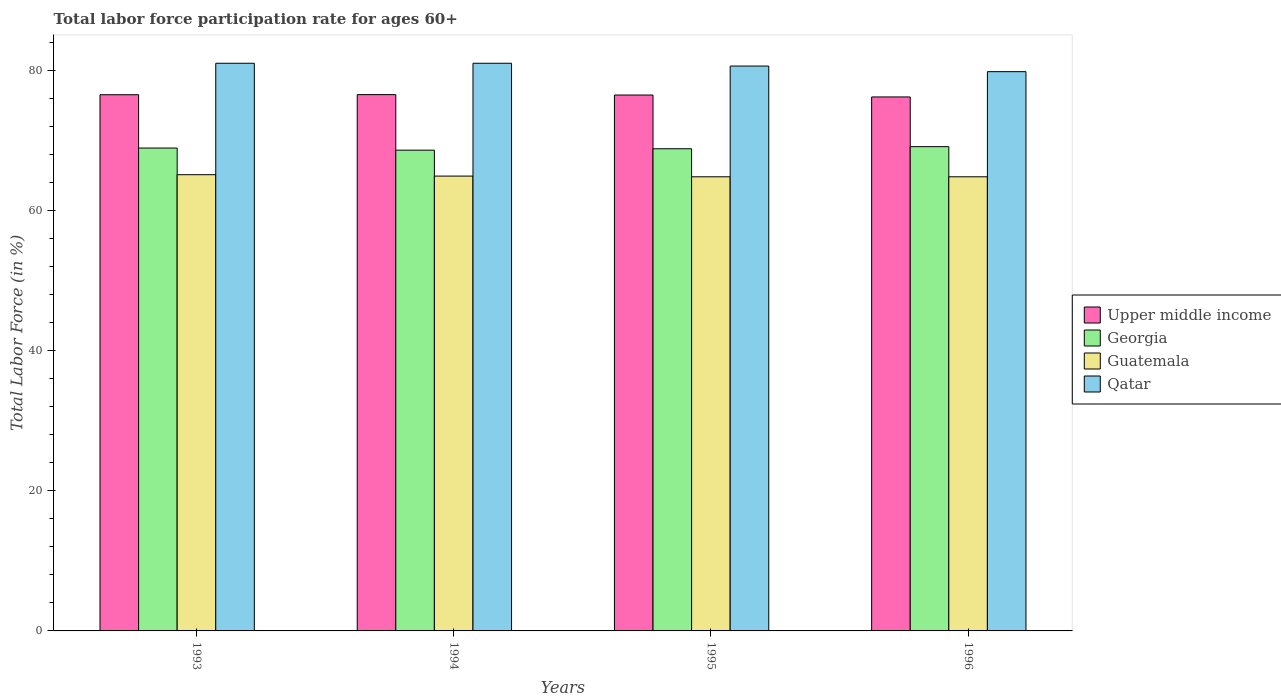How many groups of bars are there?
Offer a terse response. 4. Are the number of bars per tick equal to the number of legend labels?
Ensure brevity in your answer.  Yes. In how many cases, is the number of bars for a given year not equal to the number of legend labels?
Give a very brief answer. 0. What is the labor force participation rate in Georgia in 1995?
Provide a short and direct response. 68.8. Across all years, what is the maximum labor force participation rate in Georgia?
Keep it short and to the point. 69.1. Across all years, what is the minimum labor force participation rate in Guatemala?
Provide a succinct answer. 64.8. In which year was the labor force participation rate in Qatar maximum?
Offer a terse response. 1993. In which year was the labor force participation rate in Guatemala minimum?
Your answer should be compact. 1995. What is the total labor force participation rate in Guatemala in the graph?
Give a very brief answer. 259.6. What is the difference between the labor force participation rate in Georgia in 1993 and that in 1994?
Your answer should be compact. 0.3. What is the difference between the labor force participation rate in Qatar in 1993 and the labor force participation rate in Upper middle income in 1995?
Provide a short and direct response. 4.53. What is the average labor force participation rate in Georgia per year?
Provide a short and direct response. 68.85. In the year 1996, what is the difference between the labor force participation rate in Qatar and labor force participation rate in Upper middle income?
Offer a terse response. 3.61. In how many years, is the labor force participation rate in Qatar greater than 40 %?
Your answer should be very brief. 4. What is the ratio of the labor force participation rate in Georgia in 1993 to that in 1994?
Provide a succinct answer. 1. Is the labor force participation rate in Georgia in 1994 less than that in 1995?
Provide a short and direct response. Yes. Is the difference between the labor force participation rate in Qatar in 1994 and 1995 greater than the difference between the labor force participation rate in Upper middle income in 1994 and 1995?
Offer a terse response. Yes. What is the difference between the highest and the second highest labor force participation rate in Georgia?
Your response must be concise. 0.2. What is the difference between the highest and the lowest labor force participation rate in Upper middle income?
Your answer should be compact. 0.33. In how many years, is the labor force participation rate in Upper middle income greater than the average labor force participation rate in Upper middle income taken over all years?
Your response must be concise. 3. Is the sum of the labor force participation rate in Georgia in 1995 and 1996 greater than the maximum labor force participation rate in Guatemala across all years?
Ensure brevity in your answer.  Yes. What does the 3rd bar from the left in 1994 represents?
Your response must be concise. Guatemala. What does the 3rd bar from the right in 1995 represents?
Your answer should be compact. Georgia. How many bars are there?
Give a very brief answer. 16. Are all the bars in the graph horizontal?
Keep it short and to the point. No. How many years are there in the graph?
Your answer should be compact. 4. What is the difference between two consecutive major ticks on the Y-axis?
Your answer should be compact. 20. Are the values on the major ticks of Y-axis written in scientific E-notation?
Offer a terse response. No. Does the graph contain any zero values?
Make the answer very short. No. How are the legend labels stacked?
Your response must be concise. Vertical. What is the title of the graph?
Ensure brevity in your answer.  Total labor force participation rate for ages 60+. What is the label or title of the X-axis?
Provide a short and direct response. Years. What is the label or title of the Y-axis?
Offer a terse response. Total Labor Force (in %). What is the Total Labor Force (in %) in Upper middle income in 1993?
Provide a short and direct response. 76.51. What is the Total Labor Force (in %) of Georgia in 1993?
Keep it short and to the point. 68.9. What is the Total Labor Force (in %) of Guatemala in 1993?
Make the answer very short. 65.1. What is the Total Labor Force (in %) in Qatar in 1993?
Make the answer very short. 81. What is the Total Labor Force (in %) of Upper middle income in 1994?
Your answer should be compact. 76.53. What is the Total Labor Force (in %) in Georgia in 1994?
Make the answer very short. 68.6. What is the Total Labor Force (in %) in Guatemala in 1994?
Offer a very short reply. 64.9. What is the Total Labor Force (in %) of Upper middle income in 1995?
Your answer should be very brief. 76.47. What is the Total Labor Force (in %) in Georgia in 1995?
Provide a succinct answer. 68.8. What is the Total Labor Force (in %) of Guatemala in 1995?
Your answer should be very brief. 64.8. What is the Total Labor Force (in %) in Qatar in 1995?
Provide a succinct answer. 80.6. What is the Total Labor Force (in %) of Upper middle income in 1996?
Provide a succinct answer. 76.19. What is the Total Labor Force (in %) in Georgia in 1996?
Offer a very short reply. 69.1. What is the Total Labor Force (in %) in Guatemala in 1996?
Offer a terse response. 64.8. What is the Total Labor Force (in %) of Qatar in 1996?
Offer a terse response. 79.8. Across all years, what is the maximum Total Labor Force (in %) in Upper middle income?
Keep it short and to the point. 76.53. Across all years, what is the maximum Total Labor Force (in %) in Georgia?
Your response must be concise. 69.1. Across all years, what is the maximum Total Labor Force (in %) of Guatemala?
Your answer should be very brief. 65.1. Across all years, what is the maximum Total Labor Force (in %) of Qatar?
Provide a short and direct response. 81. Across all years, what is the minimum Total Labor Force (in %) of Upper middle income?
Your response must be concise. 76.19. Across all years, what is the minimum Total Labor Force (in %) of Georgia?
Your answer should be very brief. 68.6. Across all years, what is the minimum Total Labor Force (in %) in Guatemala?
Make the answer very short. 64.8. Across all years, what is the minimum Total Labor Force (in %) of Qatar?
Your answer should be compact. 79.8. What is the total Total Labor Force (in %) in Upper middle income in the graph?
Offer a terse response. 305.7. What is the total Total Labor Force (in %) in Georgia in the graph?
Make the answer very short. 275.4. What is the total Total Labor Force (in %) in Guatemala in the graph?
Keep it short and to the point. 259.6. What is the total Total Labor Force (in %) of Qatar in the graph?
Ensure brevity in your answer.  322.4. What is the difference between the Total Labor Force (in %) in Upper middle income in 1993 and that in 1994?
Provide a succinct answer. -0.02. What is the difference between the Total Labor Force (in %) in Georgia in 1993 and that in 1994?
Your response must be concise. 0.3. What is the difference between the Total Labor Force (in %) of Upper middle income in 1993 and that in 1995?
Provide a short and direct response. 0.04. What is the difference between the Total Labor Force (in %) in Upper middle income in 1993 and that in 1996?
Provide a short and direct response. 0.32. What is the difference between the Total Labor Force (in %) in Georgia in 1993 and that in 1996?
Your answer should be very brief. -0.2. What is the difference between the Total Labor Force (in %) in Qatar in 1993 and that in 1996?
Ensure brevity in your answer.  1.2. What is the difference between the Total Labor Force (in %) in Upper middle income in 1994 and that in 1995?
Give a very brief answer. 0.06. What is the difference between the Total Labor Force (in %) in Georgia in 1994 and that in 1996?
Your answer should be compact. -0.5. What is the difference between the Total Labor Force (in %) of Upper middle income in 1995 and that in 1996?
Provide a short and direct response. 0.28. What is the difference between the Total Labor Force (in %) in Guatemala in 1995 and that in 1996?
Make the answer very short. 0. What is the difference between the Total Labor Force (in %) of Upper middle income in 1993 and the Total Labor Force (in %) of Georgia in 1994?
Your response must be concise. 7.91. What is the difference between the Total Labor Force (in %) in Upper middle income in 1993 and the Total Labor Force (in %) in Guatemala in 1994?
Provide a succinct answer. 11.61. What is the difference between the Total Labor Force (in %) in Upper middle income in 1993 and the Total Labor Force (in %) in Qatar in 1994?
Ensure brevity in your answer.  -4.49. What is the difference between the Total Labor Force (in %) of Georgia in 1993 and the Total Labor Force (in %) of Guatemala in 1994?
Offer a terse response. 4. What is the difference between the Total Labor Force (in %) of Georgia in 1993 and the Total Labor Force (in %) of Qatar in 1994?
Provide a short and direct response. -12.1. What is the difference between the Total Labor Force (in %) in Guatemala in 1993 and the Total Labor Force (in %) in Qatar in 1994?
Keep it short and to the point. -15.9. What is the difference between the Total Labor Force (in %) of Upper middle income in 1993 and the Total Labor Force (in %) of Georgia in 1995?
Your answer should be compact. 7.71. What is the difference between the Total Labor Force (in %) of Upper middle income in 1993 and the Total Labor Force (in %) of Guatemala in 1995?
Provide a short and direct response. 11.71. What is the difference between the Total Labor Force (in %) of Upper middle income in 1993 and the Total Labor Force (in %) of Qatar in 1995?
Ensure brevity in your answer.  -4.09. What is the difference between the Total Labor Force (in %) in Georgia in 1993 and the Total Labor Force (in %) in Guatemala in 1995?
Your answer should be very brief. 4.1. What is the difference between the Total Labor Force (in %) of Georgia in 1993 and the Total Labor Force (in %) of Qatar in 1995?
Ensure brevity in your answer.  -11.7. What is the difference between the Total Labor Force (in %) in Guatemala in 1993 and the Total Labor Force (in %) in Qatar in 1995?
Your answer should be compact. -15.5. What is the difference between the Total Labor Force (in %) in Upper middle income in 1993 and the Total Labor Force (in %) in Georgia in 1996?
Offer a very short reply. 7.41. What is the difference between the Total Labor Force (in %) in Upper middle income in 1993 and the Total Labor Force (in %) in Guatemala in 1996?
Your response must be concise. 11.71. What is the difference between the Total Labor Force (in %) in Upper middle income in 1993 and the Total Labor Force (in %) in Qatar in 1996?
Your response must be concise. -3.29. What is the difference between the Total Labor Force (in %) in Georgia in 1993 and the Total Labor Force (in %) in Qatar in 1996?
Offer a very short reply. -10.9. What is the difference between the Total Labor Force (in %) in Guatemala in 1993 and the Total Labor Force (in %) in Qatar in 1996?
Keep it short and to the point. -14.7. What is the difference between the Total Labor Force (in %) of Upper middle income in 1994 and the Total Labor Force (in %) of Georgia in 1995?
Give a very brief answer. 7.73. What is the difference between the Total Labor Force (in %) in Upper middle income in 1994 and the Total Labor Force (in %) in Guatemala in 1995?
Your answer should be compact. 11.73. What is the difference between the Total Labor Force (in %) of Upper middle income in 1994 and the Total Labor Force (in %) of Qatar in 1995?
Ensure brevity in your answer.  -4.07. What is the difference between the Total Labor Force (in %) in Georgia in 1994 and the Total Labor Force (in %) in Guatemala in 1995?
Offer a terse response. 3.8. What is the difference between the Total Labor Force (in %) in Guatemala in 1994 and the Total Labor Force (in %) in Qatar in 1995?
Make the answer very short. -15.7. What is the difference between the Total Labor Force (in %) of Upper middle income in 1994 and the Total Labor Force (in %) of Georgia in 1996?
Your answer should be very brief. 7.43. What is the difference between the Total Labor Force (in %) of Upper middle income in 1994 and the Total Labor Force (in %) of Guatemala in 1996?
Ensure brevity in your answer.  11.73. What is the difference between the Total Labor Force (in %) in Upper middle income in 1994 and the Total Labor Force (in %) in Qatar in 1996?
Offer a terse response. -3.27. What is the difference between the Total Labor Force (in %) of Georgia in 1994 and the Total Labor Force (in %) of Guatemala in 1996?
Keep it short and to the point. 3.8. What is the difference between the Total Labor Force (in %) of Georgia in 1994 and the Total Labor Force (in %) of Qatar in 1996?
Offer a terse response. -11.2. What is the difference between the Total Labor Force (in %) in Guatemala in 1994 and the Total Labor Force (in %) in Qatar in 1996?
Provide a short and direct response. -14.9. What is the difference between the Total Labor Force (in %) of Upper middle income in 1995 and the Total Labor Force (in %) of Georgia in 1996?
Ensure brevity in your answer.  7.37. What is the difference between the Total Labor Force (in %) in Upper middle income in 1995 and the Total Labor Force (in %) in Guatemala in 1996?
Keep it short and to the point. 11.67. What is the difference between the Total Labor Force (in %) of Upper middle income in 1995 and the Total Labor Force (in %) of Qatar in 1996?
Your answer should be very brief. -3.33. What is the difference between the Total Labor Force (in %) of Georgia in 1995 and the Total Labor Force (in %) of Guatemala in 1996?
Give a very brief answer. 4. What is the difference between the Total Labor Force (in %) in Guatemala in 1995 and the Total Labor Force (in %) in Qatar in 1996?
Make the answer very short. -15. What is the average Total Labor Force (in %) in Upper middle income per year?
Keep it short and to the point. 76.42. What is the average Total Labor Force (in %) of Georgia per year?
Make the answer very short. 68.85. What is the average Total Labor Force (in %) in Guatemala per year?
Your response must be concise. 64.9. What is the average Total Labor Force (in %) in Qatar per year?
Ensure brevity in your answer.  80.6. In the year 1993, what is the difference between the Total Labor Force (in %) in Upper middle income and Total Labor Force (in %) in Georgia?
Provide a short and direct response. 7.61. In the year 1993, what is the difference between the Total Labor Force (in %) in Upper middle income and Total Labor Force (in %) in Guatemala?
Your response must be concise. 11.41. In the year 1993, what is the difference between the Total Labor Force (in %) of Upper middle income and Total Labor Force (in %) of Qatar?
Offer a terse response. -4.49. In the year 1993, what is the difference between the Total Labor Force (in %) in Guatemala and Total Labor Force (in %) in Qatar?
Make the answer very short. -15.9. In the year 1994, what is the difference between the Total Labor Force (in %) in Upper middle income and Total Labor Force (in %) in Georgia?
Provide a succinct answer. 7.93. In the year 1994, what is the difference between the Total Labor Force (in %) of Upper middle income and Total Labor Force (in %) of Guatemala?
Give a very brief answer. 11.63. In the year 1994, what is the difference between the Total Labor Force (in %) in Upper middle income and Total Labor Force (in %) in Qatar?
Offer a very short reply. -4.47. In the year 1994, what is the difference between the Total Labor Force (in %) of Guatemala and Total Labor Force (in %) of Qatar?
Keep it short and to the point. -16.1. In the year 1995, what is the difference between the Total Labor Force (in %) of Upper middle income and Total Labor Force (in %) of Georgia?
Give a very brief answer. 7.67. In the year 1995, what is the difference between the Total Labor Force (in %) of Upper middle income and Total Labor Force (in %) of Guatemala?
Your response must be concise. 11.67. In the year 1995, what is the difference between the Total Labor Force (in %) of Upper middle income and Total Labor Force (in %) of Qatar?
Offer a very short reply. -4.13. In the year 1995, what is the difference between the Total Labor Force (in %) of Guatemala and Total Labor Force (in %) of Qatar?
Offer a terse response. -15.8. In the year 1996, what is the difference between the Total Labor Force (in %) of Upper middle income and Total Labor Force (in %) of Georgia?
Offer a terse response. 7.09. In the year 1996, what is the difference between the Total Labor Force (in %) of Upper middle income and Total Labor Force (in %) of Guatemala?
Offer a very short reply. 11.39. In the year 1996, what is the difference between the Total Labor Force (in %) of Upper middle income and Total Labor Force (in %) of Qatar?
Keep it short and to the point. -3.61. In the year 1996, what is the difference between the Total Labor Force (in %) in Georgia and Total Labor Force (in %) in Guatemala?
Offer a terse response. 4.3. In the year 1996, what is the difference between the Total Labor Force (in %) in Georgia and Total Labor Force (in %) in Qatar?
Your response must be concise. -10.7. In the year 1996, what is the difference between the Total Labor Force (in %) of Guatemala and Total Labor Force (in %) of Qatar?
Give a very brief answer. -15. What is the ratio of the Total Labor Force (in %) in Georgia in 1993 to that in 1994?
Your answer should be very brief. 1. What is the ratio of the Total Labor Force (in %) of Qatar in 1993 to that in 1994?
Your response must be concise. 1. What is the ratio of the Total Labor Force (in %) in Upper middle income in 1993 to that in 1995?
Make the answer very short. 1. What is the ratio of the Total Labor Force (in %) in Georgia in 1993 to that in 1995?
Offer a terse response. 1. What is the ratio of the Total Labor Force (in %) in Upper middle income in 1993 to that in 1996?
Your answer should be compact. 1. What is the ratio of the Total Labor Force (in %) in Georgia in 1993 to that in 1996?
Provide a short and direct response. 1. What is the ratio of the Total Labor Force (in %) in Guatemala in 1993 to that in 1996?
Give a very brief answer. 1. What is the ratio of the Total Labor Force (in %) of Qatar in 1994 to that in 1995?
Give a very brief answer. 1. What is the ratio of the Total Labor Force (in %) in Upper middle income in 1994 to that in 1996?
Give a very brief answer. 1. What is the ratio of the Total Labor Force (in %) in Guatemala in 1994 to that in 1996?
Offer a terse response. 1. What is the ratio of the Total Labor Force (in %) in Qatar in 1994 to that in 1996?
Your answer should be very brief. 1.01. What is the ratio of the Total Labor Force (in %) in Upper middle income in 1995 to that in 1996?
Your answer should be very brief. 1. What is the difference between the highest and the second highest Total Labor Force (in %) in Upper middle income?
Offer a terse response. 0.02. What is the difference between the highest and the second highest Total Labor Force (in %) of Georgia?
Provide a succinct answer. 0.2. What is the difference between the highest and the second highest Total Labor Force (in %) of Guatemala?
Offer a very short reply. 0.2. What is the difference between the highest and the lowest Total Labor Force (in %) of Qatar?
Your answer should be compact. 1.2. 